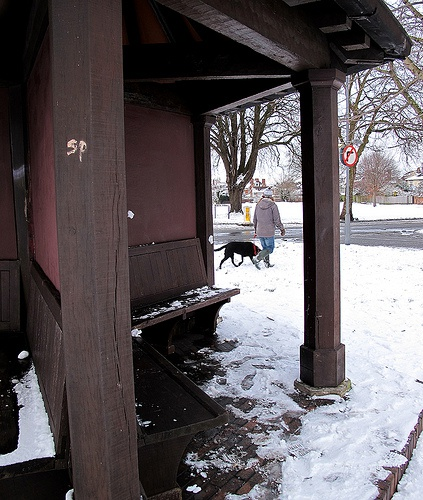Describe the objects in this image and their specific colors. I can see bench in black, darkgray, and lightgray tones, bench in black, gray, and lavender tones, bench in black, gray, and darkgray tones, people in black and gray tones, and dog in black, gray, darkgray, and white tones in this image. 